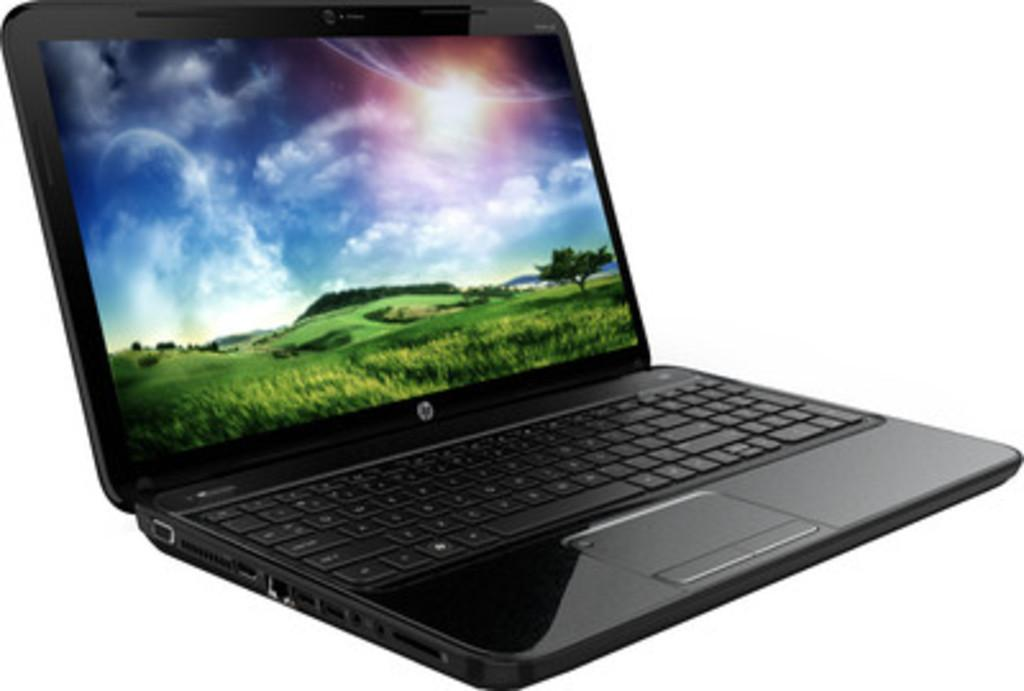What electronic device is visible in the image? There is a laptop in the image. What is displayed on the laptop screen? The laptop screen displays grass, trees, mountains, and the sky. Can you describe the landscape depicted on the laptop screen? The laptop screen displays a landscape with grass, trees, mountains, and the sky. What type of mint can be seen growing near the laptop in the image? There is no mint plant visible in the image; it only shows a laptop with a landscape displayed on the screen. 